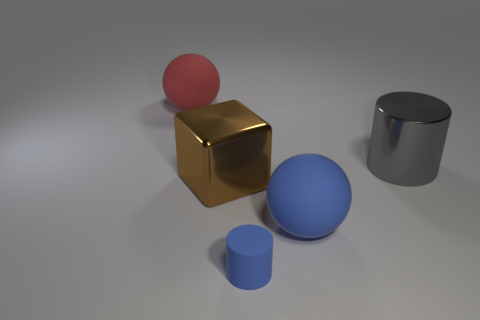Do the ball right of the large brown cube and the matte cylinder in front of the large red matte sphere have the same size?
Give a very brief answer. No. What number of things are either blue metallic objects or matte balls that are right of the big cube?
Your answer should be very brief. 1. Are there any other big brown shiny things of the same shape as the large brown metallic object?
Ensure brevity in your answer.  No. There is a rubber ball left of the matte object that is in front of the big blue matte thing; how big is it?
Ensure brevity in your answer.  Large. Does the large shiny cylinder have the same color as the matte cylinder?
Your answer should be compact. No. How many rubber objects are either blocks or tiny red balls?
Offer a terse response. 0. How many small red metallic spheres are there?
Your answer should be very brief. 0. Are the cylinder on the right side of the small blue cylinder and the ball in front of the gray metal cylinder made of the same material?
Your answer should be very brief. No. There is another rubber object that is the same shape as the large gray object; what color is it?
Provide a succinct answer. Blue. What material is the ball to the left of the cylinder to the left of the gray shiny cylinder?
Your answer should be compact. Rubber. 